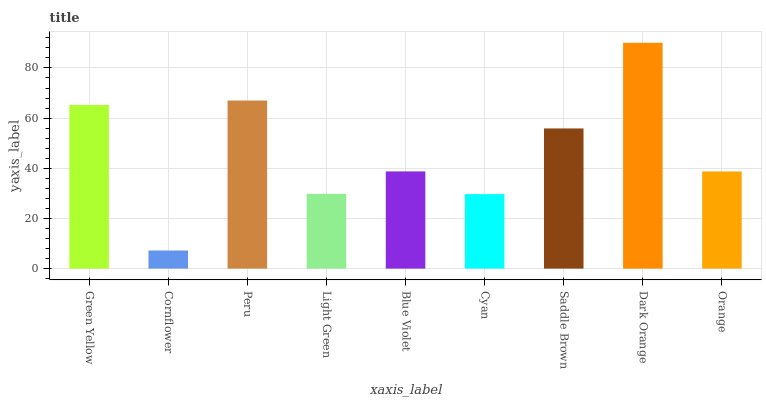Is Cornflower the minimum?
Answer yes or no. Yes. Is Dark Orange the maximum?
Answer yes or no. Yes. Is Peru the minimum?
Answer yes or no. No. Is Peru the maximum?
Answer yes or no. No. Is Peru greater than Cornflower?
Answer yes or no. Yes. Is Cornflower less than Peru?
Answer yes or no. Yes. Is Cornflower greater than Peru?
Answer yes or no. No. Is Peru less than Cornflower?
Answer yes or no. No. Is Blue Violet the high median?
Answer yes or no. Yes. Is Blue Violet the low median?
Answer yes or no. Yes. Is Cyan the high median?
Answer yes or no. No. Is Cornflower the low median?
Answer yes or no. No. 